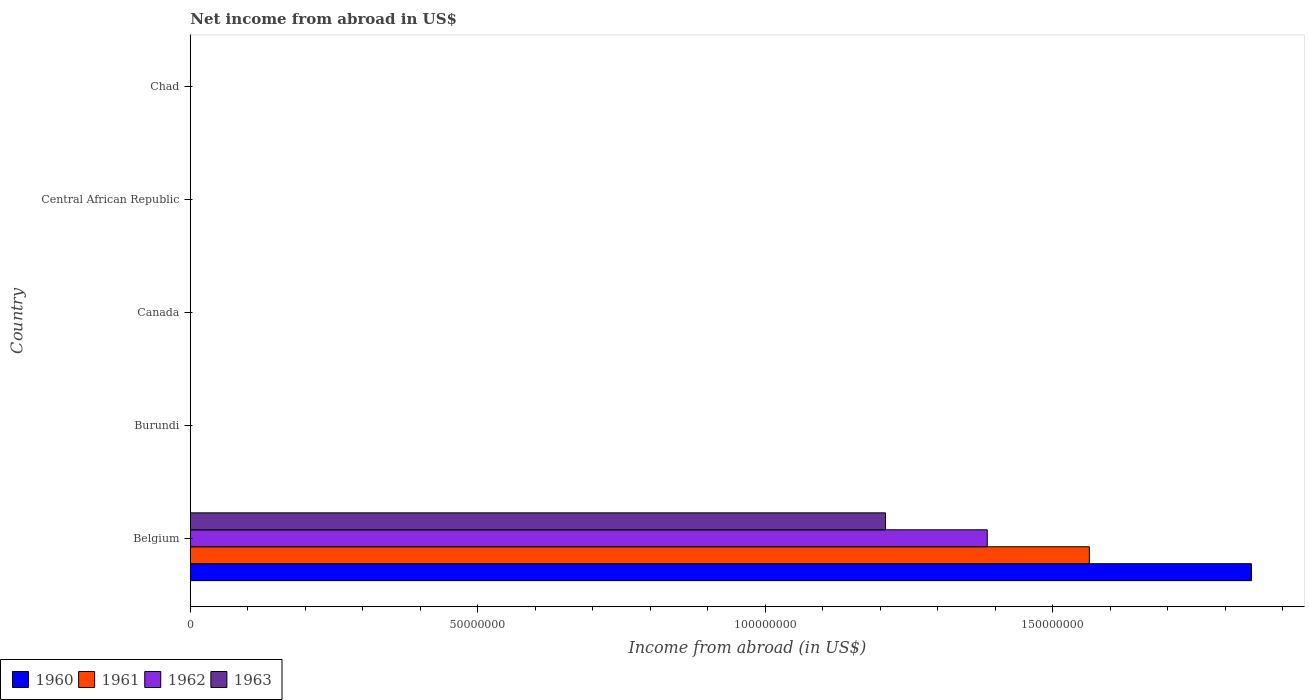How many different coloured bars are there?
Ensure brevity in your answer.  4. What is the label of the 1st group of bars from the top?
Provide a short and direct response. Chad. What is the net income from abroad in 1962 in Central African Republic?
Provide a short and direct response. 0. Across all countries, what is the maximum net income from abroad in 1962?
Your answer should be very brief. 1.39e+08. What is the total net income from abroad in 1963 in the graph?
Provide a short and direct response. 1.21e+08. What is the difference between the net income from abroad in 1963 in Burundi and the net income from abroad in 1961 in Canada?
Offer a very short reply. 0. What is the average net income from abroad in 1963 per country?
Provide a succinct answer. 2.42e+07. What is the difference between the net income from abroad in 1962 and net income from abroad in 1963 in Belgium?
Your answer should be compact. 1.77e+07. What is the difference between the highest and the lowest net income from abroad in 1963?
Keep it short and to the point. 1.21e+08. In how many countries, is the net income from abroad in 1963 greater than the average net income from abroad in 1963 taken over all countries?
Offer a very short reply. 1. Is it the case that in every country, the sum of the net income from abroad in 1961 and net income from abroad in 1963 is greater than the net income from abroad in 1962?
Offer a very short reply. No. Are all the bars in the graph horizontal?
Keep it short and to the point. Yes. How many countries are there in the graph?
Your answer should be compact. 5. Does the graph contain grids?
Keep it short and to the point. No. How many legend labels are there?
Keep it short and to the point. 4. How are the legend labels stacked?
Keep it short and to the point. Horizontal. What is the title of the graph?
Ensure brevity in your answer.  Net income from abroad in US$. Does "2012" appear as one of the legend labels in the graph?
Offer a terse response. No. What is the label or title of the X-axis?
Give a very brief answer. Income from abroad (in US$). What is the Income from abroad (in US$) of 1960 in Belgium?
Offer a terse response. 1.85e+08. What is the Income from abroad (in US$) in 1961 in Belgium?
Your response must be concise. 1.56e+08. What is the Income from abroad (in US$) of 1962 in Belgium?
Provide a succinct answer. 1.39e+08. What is the Income from abroad (in US$) in 1963 in Belgium?
Your response must be concise. 1.21e+08. What is the Income from abroad (in US$) of 1962 in Burundi?
Your answer should be compact. 0. What is the Income from abroad (in US$) in 1960 in Canada?
Provide a short and direct response. 0. What is the Income from abroad (in US$) in 1961 in Canada?
Offer a terse response. 0. What is the Income from abroad (in US$) in 1962 in Canada?
Provide a short and direct response. 0. What is the Income from abroad (in US$) in 1963 in Canada?
Provide a short and direct response. 0. What is the Income from abroad (in US$) of 1960 in Central African Republic?
Your response must be concise. 0. What is the Income from abroad (in US$) of 1962 in Chad?
Ensure brevity in your answer.  0. What is the Income from abroad (in US$) in 1963 in Chad?
Offer a terse response. 0. Across all countries, what is the maximum Income from abroad (in US$) of 1960?
Your response must be concise. 1.85e+08. Across all countries, what is the maximum Income from abroad (in US$) in 1961?
Offer a very short reply. 1.56e+08. Across all countries, what is the maximum Income from abroad (in US$) in 1962?
Provide a short and direct response. 1.39e+08. Across all countries, what is the maximum Income from abroad (in US$) of 1963?
Ensure brevity in your answer.  1.21e+08. Across all countries, what is the minimum Income from abroad (in US$) in 1961?
Give a very brief answer. 0. Across all countries, what is the minimum Income from abroad (in US$) of 1962?
Offer a terse response. 0. Across all countries, what is the minimum Income from abroad (in US$) of 1963?
Offer a terse response. 0. What is the total Income from abroad (in US$) in 1960 in the graph?
Ensure brevity in your answer.  1.85e+08. What is the total Income from abroad (in US$) in 1961 in the graph?
Your answer should be compact. 1.56e+08. What is the total Income from abroad (in US$) of 1962 in the graph?
Offer a very short reply. 1.39e+08. What is the total Income from abroad (in US$) in 1963 in the graph?
Provide a short and direct response. 1.21e+08. What is the average Income from abroad (in US$) in 1960 per country?
Your answer should be compact. 3.69e+07. What is the average Income from abroad (in US$) of 1961 per country?
Your answer should be compact. 3.13e+07. What is the average Income from abroad (in US$) of 1962 per country?
Ensure brevity in your answer.  2.77e+07. What is the average Income from abroad (in US$) of 1963 per country?
Provide a succinct answer. 2.42e+07. What is the difference between the Income from abroad (in US$) of 1960 and Income from abroad (in US$) of 1961 in Belgium?
Provide a succinct answer. 2.82e+07. What is the difference between the Income from abroad (in US$) in 1960 and Income from abroad (in US$) in 1962 in Belgium?
Your answer should be compact. 4.60e+07. What is the difference between the Income from abroad (in US$) in 1960 and Income from abroad (in US$) in 1963 in Belgium?
Make the answer very short. 6.37e+07. What is the difference between the Income from abroad (in US$) in 1961 and Income from abroad (in US$) in 1962 in Belgium?
Make the answer very short. 1.78e+07. What is the difference between the Income from abroad (in US$) of 1961 and Income from abroad (in US$) of 1963 in Belgium?
Your response must be concise. 3.55e+07. What is the difference between the Income from abroad (in US$) in 1962 and Income from abroad (in US$) in 1963 in Belgium?
Your answer should be very brief. 1.77e+07. What is the difference between the highest and the lowest Income from abroad (in US$) in 1960?
Your response must be concise. 1.85e+08. What is the difference between the highest and the lowest Income from abroad (in US$) in 1961?
Offer a very short reply. 1.56e+08. What is the difference between the highest and the lowest Income from abroad (in US$) of 1962?
Keep it short and to the point. 1.39e+08. What is the difference between the highest and the lowest Income from abroad (in US$) in 1963?
Give a very brief answer. 1.21e+08. 